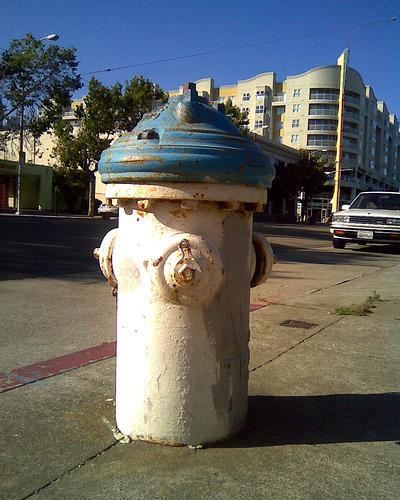Question: how many animals are seen?
Choices:
A. 7.
B. 8.
C. 9.
D. 0.
Answer with the letter. Answer: D Question: what color is the sky?
Choices:
A. Red.
B. Black.
C. Blue.
D. Grey.
Answer with the letter. Answer: C Question: what is in the background?
Choices:
A. Trees.
B. Mountains.
C. Buildings.
D. Fences.
Answer with the letter. Answer: C Question: why is the car moving?
Choices:
A. Someone is driving.
B. It's going.
C. It's leaving.
D. It's rolling.
Answer with the letter. Answer: A 